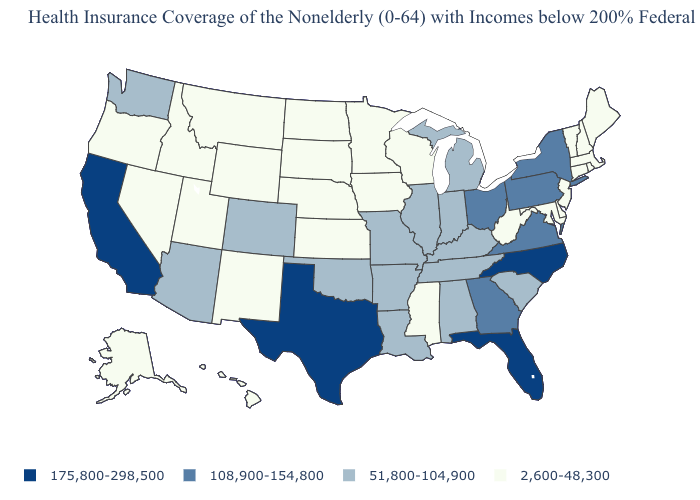Which states have the lowest value in the USA?
Keep it brief. Alaska, Connecticut, Delaware, Hawaii, Idaho, Iowa, Kansas, Maine, Maryland, Massachusetts, Minnesota, Mississippi, Montana, Nebraska, Nevada, New Hampshire, New Jersey, New Mexico, North Dakota, Oregon, Rhode Island, South Dakota, Utah, Vermont, West Virginia, Wisconsin, Wyoming. What is the value of Hawaii?
Quick response, please. 2,600-48,300. What is the highest value in states that border South Carolina?
Answer briefly. 175,800-298,500. Among the states that border Virginia , which have the highest value?
Short answer required. North Carolina. Name the states that have a value in the range 51,800-104,900?
Answer briefly. Alabama, Arizona, Arkansas, Colorado, Illinois, Indiana, Kentucky, Louisiana, Michigan, Missouri, Oklahoma, South Carolina, Tennessee, Washington. What is the lowest value in the USA?
Short answer required. 2,600-48,300. Does Rhode Island have the highest value in the USA?
Keep it brief. No. Does the map have missing data?
Write a very short answer. No. Does Tennessee have a higher value than Florida?
Be succinct. No. What is the value of Tennessee?
Concise answer only. 51,800-104,900. Which states have the lowest value in the USA?
Be succinct. Alaska, Connecticut, Delaware, Hawaii, Idaho, Iowa, Kansas, Maine, Maryland, Massachusetts, Minnesota, Mississippi, Montana, Nebraska, Nevada, New Hampshire, New Jersey, New Mexico, North Dakota, Oregon, Rhode Island, South Dakota, Utah, Vermont, West Virginia, Wisconsin, Wyoming. What is the lowest value in the West?
Be succinct. 2,600-48,300. Does the first symbol in the legend represent the smallest category?
Short answer required. No. Does Delaware have the same value as Hawaii?
Short answer required. Yes. What is the value of Louisiana?
Concise answer only. 51,800-104,900. 